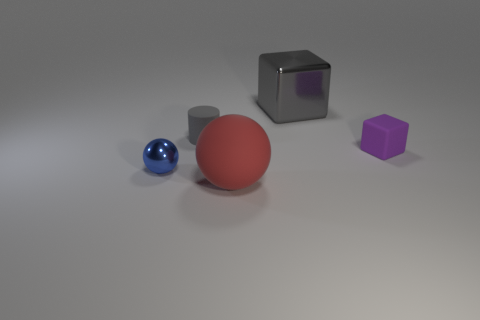The metal object that is behind the tiny sphere has what shape?
Give a very brief answer. Cube. Does the tiny blue thing have the same shape as the thing behind the gray cylinder?
Your answer should be compact. No. There is a thing that is right of the blue ball and in front of the purple object; what size is it?
Keep it short and to the point. Large. The tiny thing that is to the left of the purple thing and behind the small sphere is what color?
Keep it short and to the point. Gray. Is there anything else that has the same material as the cylinder?
Offer a very short reply. Yes. Are there fewer red things left of the blue shiny sphere than tiny rubber cubes that are behind the large gray metallic thing?
Make the answer very short. No. Are there any other things that are the same color as the cylinder?
Keep it short and to the point. Yes. What shape is the large rubber thing?
Your answer should be very brief. Sphere. The sphere that is made of the same material as the small purple block is what color?
Your answer should be very brief. Red. Are there more large cyan matte cubes than big metallic blocks?
Ensure brevity in your answer.  No. 